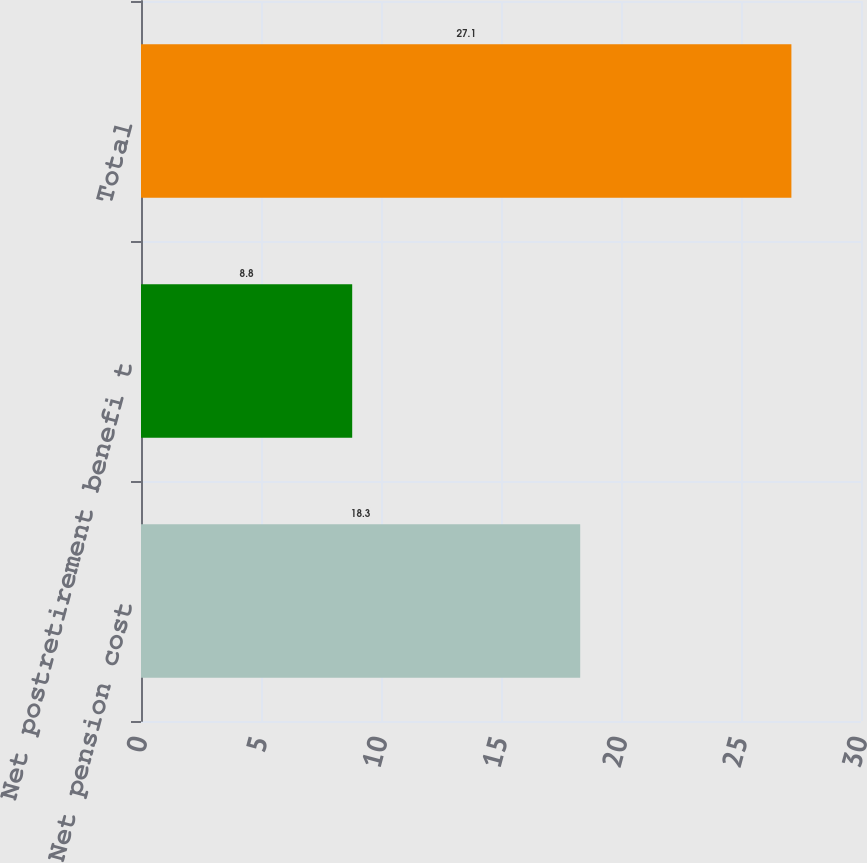Convert chart to OTSL. <chart><loc_0><loc_0><loc_500><loc_500><bar_chart><fcel>Net pension cost<fcel>Net postretirement benefi t<fcel>Total<nl><fcel>18.3<fcel>8.8<fcel>27.1<nl></chart> 